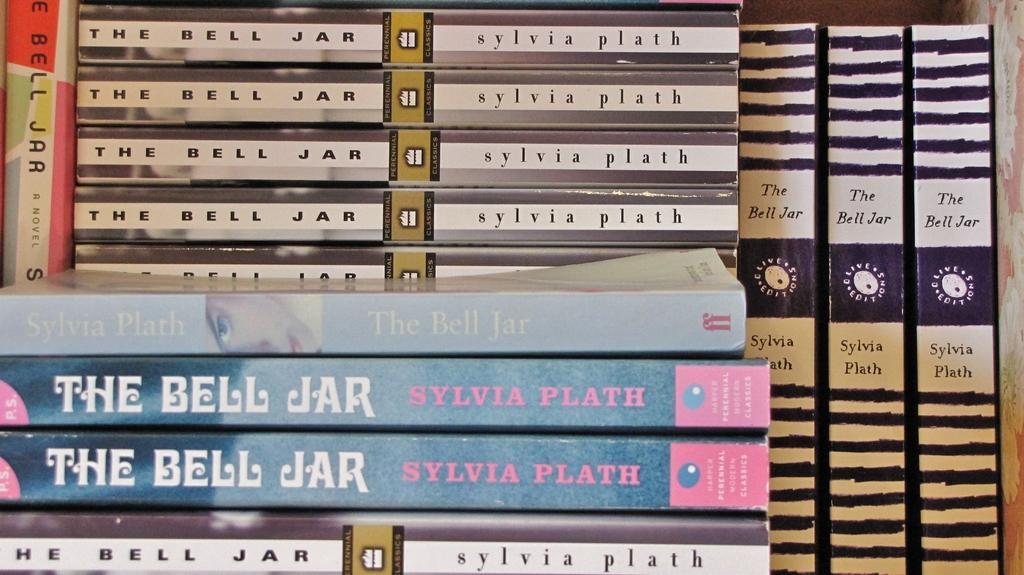<image>
Relay a brief, clear account of the picture shown. A stack of books called The Bell Jar. 